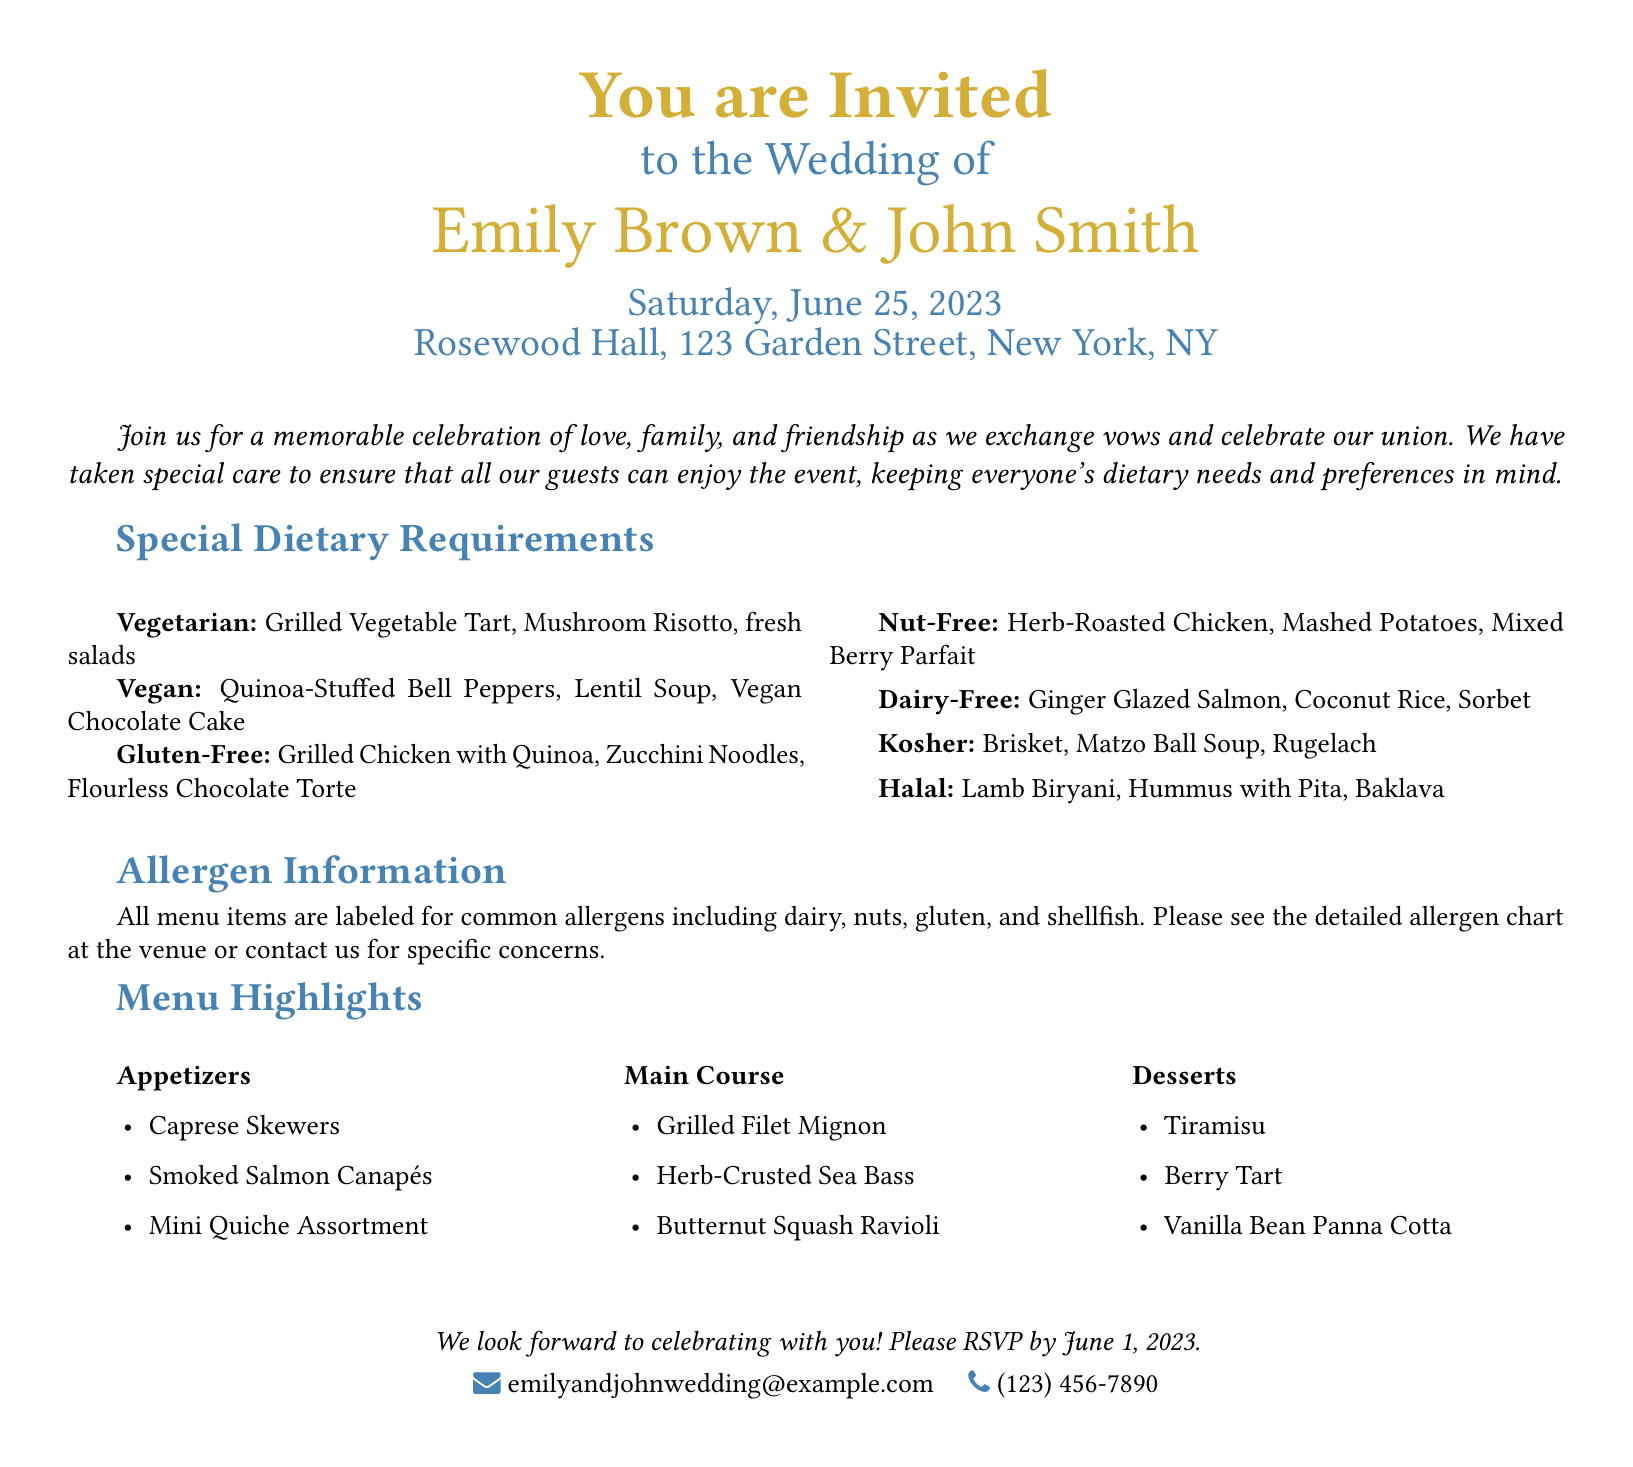What is the name of the bride? The document specifies the bride's name as Emily Brown.
Answer: Emily Brown What is the date of the wedding? The wedding date is clearly indicated in the document as Saturday, June 25, 2023.
Answer: June 25, 2023 What type of dessert is included for a vegan option? The vegan dessert listed in the document is Vegan Chocolate Cake.
Answer: Vegan Chocolate Cake What is one main course option for gluten-free guests? The document provides Grilled Chicken with Quinoa as a gluten-free main course option.
Answer: Grilled Chicken with Quinoa What type of soup is offered for kosher guests? According to the document, the kosher soup option is Matzo Ball Soup.
Answer: Matzo Ball Soup How many main course options are listed in the menu highlights? There are three main course options detailed in the menu highlights of the document.
Answer: Three What is the primary contact method for the wedding? The document provides an email address for RSVP inquiries, which is the primary contact method.
Answer: emilyandjohnwedding@example.com What is the final RSVP date mentioned in the invitation? The document states that guests should RSVP by June 1, 2023.
Answer: June 1, 2023 